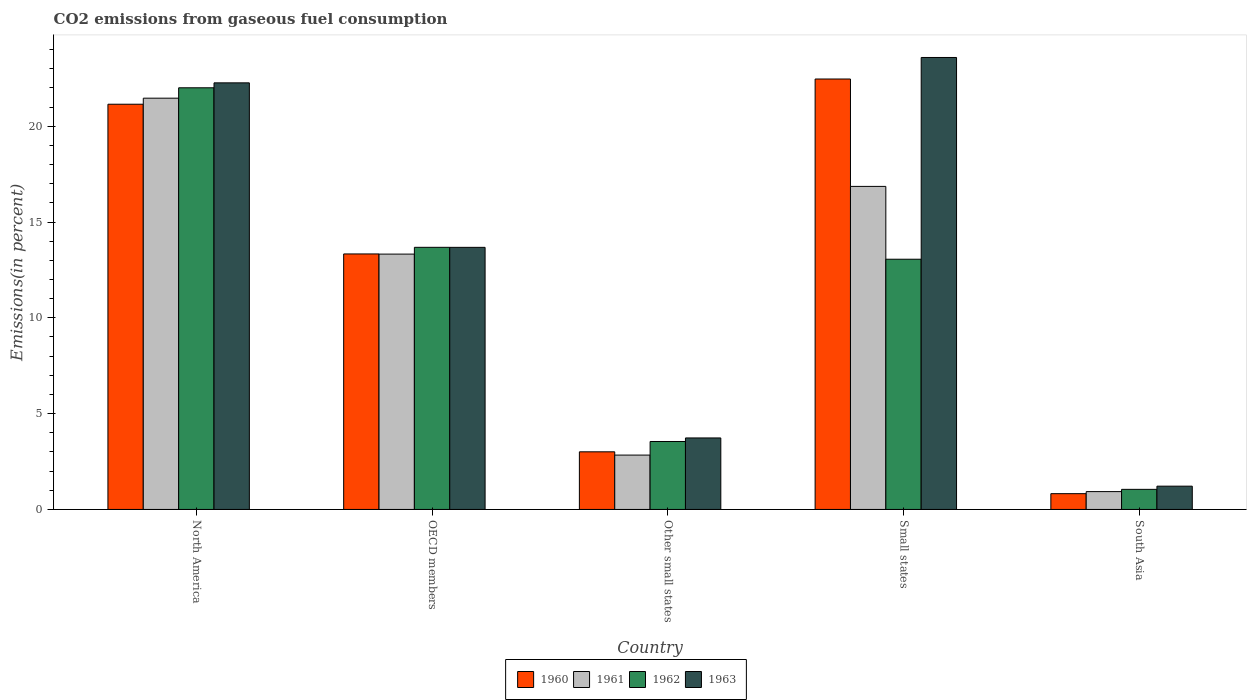How many groups of bars are there?
Make the answer very short. 5. Are the number of bars per tick equal to the number of legend labels?
Your response must be concise. Yes. How many bars are there on the 2nd tick from the right?
Provide a short and direct response. 4. In how many cases, is the number of bars for a given country not equal to the number of legend labels?
Your answer should be compact. 0. What is the total CO2 emitted in 1962 in OECD members?
Provide a short and direct response. 13.68. Across all countries, what is the maximum total CO2 emitted in 1960?
Make the answer very short. 22.46. Across all countries, what is the minimum total CO2 emitted in 1963?
Keep it short and to the point. 1.22. In which country was the total CO2 emitted in 1962 minimum?
Ensure brevity in your answer.  South Asia. What is the total total CO2 emitted in 1961 in the graph?
Offer a very short reply. 55.41. What is the difference between the total CO2 emitted in 1963 in OECD members and that in Other small states?
Your answer should be very brief. 9.95. What is the difference between the total CO2 emitted in 1962 in South Asia and the total CO2 emitted in 1961 in Other small states?
Provide a short and direct response. -1.79. What is the average total CO2 emitted in 1960 per country?
Offer a very short reply. 12.15. What is the difference between the total CO2 emitted of/in 1963 and total CO2 emitted of/in 1961 in Other small states?
Ensure brevity in your answer.  0.89. In how many countries, is the total CO2 emitted in 1963 greater than 13 %?
Your answer should be compact. 3. What is the ratio of the total CO2 emitted in 1963 in North America to that in Small states?
Offer a very short reply. 0.94. What is the difference between the highest and the second highest total CO2 emitted in 1962?
Your answer should be compact. -0.62. What is the difference between the highest and the lowest total CO2 emitted in 1963?
Provide a succinct answer. 22.37. What does the 3rd bar from the right in Other small states represents?
Keep it short and to the point. 1961. How many bars are there?
Your answer should be very brief. 20. Are all the bars in the graph horizontal?
Offer a terse response. No. How many countries are there in the graph?
Provide a short and direct response. 5. What is the difference between two consecutive major ticks on the Y-axis?
Your answer should be very brief. 5. Does the graph contain any zero values?
Your answer should be compact. No. Where does the legend appear in the graph?
Provide a succinct answer. Bottom center. What is the title of the graph?
Provide a short and direct response. CO2 emissions from gaseous fuel consumption. What is the label or title of the X-axis?
Ensure brevity in your answer.  Country. What is the label or title of the Y-axis?
Provide a succinct answer. Emissions(in percent). What is the Emissions(in percent) of 1960 in North America?
Offer a very short reply. 21.15. What is the Emissions(in percent) of 1961 in North America?
Your answer should be very brief. 21.46. What is the Emissions(in percent) in 1962 in North America?
Provide a succinct answer. 22. What is the Emissions(in percent) in 1963 in North America?
Provide a short and direct response. 22.26. What is the Emissions(in percent) of 1960 in OECD members?
Provide a short and direct response. 13.33. What is the Emissions(in percent) of 1961 in OECD members?
Offer a very short reply. 13.33. What is the Emissions(in percent) in 1962 in OECD members?
Provide a succinct answer. 13.68. What is the Emissions(in percent) in 1963 in OECD members?
Your answer should be very brief. 13.68. What is the Emissions(in percent) in 1960 in Other small states?
Give a very brief answer. 3.01. What is the Emissions(in percent) in 1961 in Other small states?
Keep it short and to the point. 2.84. What is the Emissions(in percent) in 1962 in Other small states?
Provide a short and direct response. 3.55. What is the Emissions(in percent) of 1963 in Other small states?
Offer a terse response. 3.73. What is the Emissions(in percent) in 1960 in Small states?
Provide a short and direct response. 22.46. What is the Emissions(in percent) in 1961 in Small states?
Your response must be concise. 16.86. What is the Emissions(in percent) of 1962 in Small states?
Offer a very short reply. 13.06. What is the Emissions(in percent) in 1963 in Small states?
Provide a short and direct response. 23.59. What is the Emissions(in percent) in 1960 in South Asia?
Offer a terse response. 0.82. What is the Emissions(in percent) of 1961 in South Asia?
Ensure brevity in your answer.  0.93. What is the Emissions(in percent) in 1962 in South Asia?
Keep it short and to the point. 1.05. What is the Emissions(in percent) in 1963 in South Asia?
Your answer should be compact. 1.22. Across all countries, what is the maximum Emissions(in percent) of 1960?
Provide a succinct answer. 22.46. Across all countries, what is the maximum Emissions(in percent) in 1961?
Offer a terse response. 21.46. Across all countries, what is the maximum Emissions(in percent) of 1962?
Your answer should be compact. 22. Across all countries, what is the maximum Emissions(in percent) in 1963?
Your answer should be compact. 23.59. Across all countries, what is the minimum Emissions(in percent) of 1960?
Offer a very short reply. 0.82. Across all countries, what is the minimum Emissions(in percent) of 1961?
Your answer should be very brief. 0.93. Across all countries, what is the minimum Emissions(in percent) of 1962?
Your answer should be compact. 1.05. Across all countries, what is the minimum Emissions(in percent) in 1963?
Your response must be concise. 1.22. What is the total Emissions(in percent) of 1960 in the graph?
Ensure brevity in your answer.  60.77. What is the total Emissions(in percent) in 1961 in the graph?
Your answer should be compact. 55.41. What is the total Emissions(in percent) of 1962 in the graph?
Your answer should be very brief. 53.34. What is the total Emissions(in percent) of 1963 in the graph?
Give a very brief answer. 64.47. What is the difference between the Emissions(in percent) in 1960 in North America and that in OECD members?
Provide a succinct answer. 7.81. What is the difference between the Emissions(in percent) in 1961 in North America and that in OECD members?
Give a very brief answer. 8.14. What is the difference between the Emissions(in percent) of 1962 in North America and that in OECD members?
Make the answer very short. 8.32. What is the difference between the Emissions(in percent) of 1963 in North America and that in OECD members?
Offer a very short reply. 8.58. What is the difference between the Emissions(in percent) in 1960 in North America and that in Other small states?
Make the answer very short. 18.14. What is the difference between the Emissions(in percent) in 1961 in North America and that in Other small states?
Give a very brief answer. 18.62. What is the difference between the Emissions(in percent) of 1962 in North America and that in Other small states?
Provide a succinct answer. 18.46. What is the difference between the Emissions(in percent) of 1963 in North America and that in Other small states?
Your answer should be compact. 18.53. What is the difference between the Emissions(in percent) of 1960 in North America and that in Small states?
Provide a succinct answer. -1.32. What is the difference between the Emissions(in percent) of 1961 in North America and that in Small states?
Your response must be concise. 4.6. What is the difference between the Emissions(in percent) in 1962 in North America and that in Small states?
Provide a succinct answer. 8.95. What is the difference between the Emissions(in percent) of 1963 in North America and that in Small states?
Your answer should be compact. -1.32. What is the difference between the Emissions(in percent) of 1960 in North America and that in South Asia?
Your answer should be very brief. 20.32. What is the difference between the Emissions(in percent) in 1961 in North America and that in South Asia?
Your response must be concise. 20.53. What is the difference between the Emissions(in percent) in 1962 in North America and that in South Asia?
Your answer should be very brief. 20.95. What is the difference between the Emissions(in percent) of 1963 in North America and that in South Asia?
Offer a very short reply. 21.05. What is the difference between the Emissions(in percent) in 1960 in OECD members and that in Other small states?
Your answer should be very brief. 10.33. What is the difference between the Emissions(in percent) in 1961 in OECD members and that in Other small states?
Ensure brevity in your answer.  10.49. What is the difference between the Emissions(in percent) in 1962 in OECD members and that in Other small states?
Give a very brief answer. 10.13. What is the difference between the Emissions(in percent) in 1963 in OECD members and that in Other small states?
Offer a terse response. 9.95. What is the difference between the Emissions(in percent) of 1960 in OECD members and that in Small states?
Your answer should be compact. -9.13. What is the difference between the Emissions(in percent) of 1961 in OECD members and that in Small states?
Keep it short and to the point. -3.53. What is the difference between the Emissions(in percent) in 1962 in OECD members and that in Small states?
Offer a terse response. 0.62. What is the difference between the Emissions(in percent) in 1963 in OECD members and that in Small states?
Offer a very short reply. -9.91. What is the difference between the Emissions(in percent) of 1960 in OECD members and that in South Asia?
Your response must be concise. 12.51. What is the difference between the Emissions(in percent) in 1961 in OECD members and that in South Asia?
Provide a short and direct response. 12.39. What is the difference between the Emissions(in percent) of 1962 in OECD members and that in South Asia?
Your answer should be compact. 12.63. What is the difference between the Emissions(in percent) in 1963 in OECD members and that in South Asia?
Make the answer very short. 12.46. What is the difference between the Emissions(in percent) in 1960 in Other small states and that in Small states?
Your answer should be very brief. -19.45. What is the difference between the Emissions(in percent) in 1961 in Other small states and that in Small states?
Keep it short and to the point. -14.02. What is the difference between the Emissions(in percent) in 1962 in Other small states and that in Small states?
Your answer should be compact. -9.51. What is the difference between the Emissions(in percent) of 1963 in Other small states and that in Small states?
Ensure brevity in your answer.  -19.85. What is the difference between the Emissions(in percent) of 1960 in Other small states and that in South Asia?
Your answer should be very brief. 2.18. What is the difference between the Emissions(in percent) in 1961 in Other small states and that in South Asia?
Offer a terse response. 1.91. What is the difference between the Emissions(in percent) of 1962 in Other small states and that in South Asia?
Offer a terse response. 2.5. What is the difference between the Emissions(in percent) of 1963 in Other small states and that in South Asia?
Your answer should be compact. 2.52. What is the difference between the Emissions(in percent) of 1960 in Small states and that in South Asia?
Make the answer very short. 21.64. What is the difference between the Emissions(in percent) in 1961 in Small states and that in South Asia?
Ensure brevity in your answer.  15.93. What is the difference between the Emissions(in percent) in 1962 in Small states and that in South Asia?
Give a very brief answer. 12.01. What is the difference between the Emissions(in percent) in 1963 in Small states and that in South Asia?
Offer a terse response. 22.37. What is the difference between the Emissions(in percent) in 1960 in North America and the Emissions(in percent) in 1961 in OECD members?
Give a very brief answer. 7.82. What is the difference between the Emissions(in percent) in 1960 in North America and the Emissions(in percent) in 1962 in OECD members?
Give a very brief answer. 7.47. What is the difference between the Emissions(in percent) in 1960 in North America and the Emissions(in percent) in 1963 in OECD members?
Offer a terse response. 7.47. What is the difference between the Emissions(in percent) in 1961 in North America and the Emissions(in percent) in 1962 in OECD members?
Your response must be concise. 7.78. What is the difference between the Emissions(in percent) in 1961 in North America and the Emissions(in percent) in 1963 in OECD members?
Ensure brevity in your answer.  7.78. What is the difference between the Emissions(in percent) in 1962 in North America and the Emissions(in percent) in 1963 in OECD members?
Offer a very short reply. 8.33. What is the difference between the Emissions(in percent) of 1960 in North America and the Emissions(in percent) of 1961 in Other small states?
Your answer should be compact. 18.31. What is the difference between the Emissions(in percent) of 1960 in North America and the Emissions(in percent) of 1962 in Other small states?
Make the answer very short. 17.6. What is the difference between the Emissions(in percent) of 1960 in North America and the Emissions(in percent) of 1963 in Other small states?
Offer a terse response. 17.41. What is the difference between the Emissions(in percent) of 1961 in North America and the Emissions(in percent) of 1962 in Other small states?
Offer a terse response. 17.92. What is the difference between the Emissions(in percent) in 1961 in North America and the Emissions(in percent) in 1963 in Other small states?
Keep it short and to the point. 17.73. What is the difference between the Emissions(in percent) of 1962 in North America and the Emissions(in percent) of 1963 in Other small states?
Provide a short and direct response. 18.27. What is the difference between the Emissions(in percent) in 1960 in North America and the Emissions(in percent) in 1961 in Small states?
Your answer should be very brief. 4.29. What is the difference between the Emissions(in percent) of 1960 in North America and the Emissions(in percent) of 1962 in Small states?
Offer a very short reply. 8.09. What is the difference between the Emissions(in percent) of 1960 in North America and the Emissions(in percent) of 1963 in Small states?
Offer a very short reply. -2.44. What is the difference between the Emissions(in percent) of 1961 in North America and the Emissions(in percent) of 1962 in Small states?
Provide a succinct answer. 8.4. What is the difference between the Emissions(in percent) of 1961 in North America and the Emissions(in percent) of 1963 in Small states?
Your answer should be very brief. -2.12. What is the difference between the Emissions(in percent) in 1962 in North America and the Emissions(in percent) in 1963 in Small states?
Your response must be concise. -1.58. What is the difference between the Emissions(in percent) of 1960 in North America and the Emissions(in percent) of 1961 in South Asia?
Give a very brief answer. 20.21. What is the difference between the Emissions(in percent) in 1960 in North America and the Emissions(in percent) in 1962 in South Asia?
Make the answer very short. 20.1. What is the difference between the Emissions(in percent) of 1960 in North America and the Emissions(in percent) of 1963 in South Asia?
Provide a short and direct response. 19.93. What is the difference between the Emissions(in percent) in 1961 in North America and the Emissions(in percent) in 1962 in South Asia?
Make the answer very short. 20.41. What is the difference between the Emissions(in percent) of 1961 in North America and the Emissions(in percent) of 1963 in South Asia?
Your response must be concise. 20.25. What is the difference between the Emissions(in percent) in 1962 in North America and the Emissions(in percent) in 1963 in South Asia?
Your answer should be very brief. 20.79. What is the difference between the Emissions(in percent) of 1960 in OECD members and the Emissions(in percent) of 1961 in Other small states?
Your answer should be compact. 10.5. What is the difference between the Emissions(in percent) of 1960 in OECD members and the Emissions(in percent) of 1962 in Other small states?
Offer a terse response. 9.79. What is the difference between the Emissions(in percent) of 1960 in OECD members and the Emissions(in percent) of 1963 in Other small states?
Provide a short and direct response. 9.6. What is the difference between the Emissions(in percent) of 1961 in OECD members and the Emissions(in percent) of 1962 in Other small states?
Provide a short and direct response. 9.78. What is the difference between the Emissions(in percent) of 1961 in OECD members and the Emissions(in percent) of 1963 in Other small states?
Provide a short and direct response. 9.59. What is the difference between the Emissions(in percent) in 1962 in OECD members and the Emissions(in percent) in 1963 in Other small states?
Offer a terse response. 9.95. What is the difference between the Emissions(in percent) of 1960 in OECD members and the Emissions(in percent) of 1961 in Small states?
Provide a short and direct response. -3.52. What is the difference between the Emissions(in percent) in 1960 in OECD members and the Emissions(in percent) in 1962 in Small states?
Provide a succinct answer. 0.28. What is the difference between the Emissions(in percent) of 1960 in OECD members and the Emissions(in percent) of 1963 in Small states?
Your answer should be compact. -10.25. What is the difference between the Emissions(in percent) in 1961 in OECD members and the Emissions(in percent) in 1962 in Small states?
Your answer should be compact. 0.27. What is the difference between the Emissions(in percent) in 1961 in OECD members and the Emissions(in percent) in 1963 in Small states?
Make the answer very short. -10.26. What is the difference between the Emissions(in percent) in 1962 in OECD members and the Emissions(in percent) in 1963 in Small states?
Offer a very short reply. -9.91. What is the difference between the Emissions(in percent) of 1960 in OECD members and the Emissions(in percent) of 1961 in South Asia?
Provide a succinct answer. 12.4. What is the difference between the Emissions(in percent) in 1960 in OECD members and the Emissions(in percent) in 1962 in South Asia?
Provide a succinct answer. 12.28. What is the difference between the Emissions(in percent) in 1960 in OECD members and the Emissions(in percent) in 1963 in South Asia?
Give a very brief answer. 12.12. What is the difference between the Emissions(in percent) in 1961 in OECD members and the Emissions(in percent) in 1962 in South Asia?
Your response must be concise. 12.28. What is the difference between the Emissions(in percent) in 1961 in OECD members and the Emissions(in percent) in 1963 in South Asia?
Keep it short and to the point. 12.11. What is the difference between the Emissions(in percent) in 1962 in OECD members and the Emissions(in percent) in 1963 in South Asia?
Your response must be concise. 12.46. What is the difference between the Emissions(in percent) of 1960 in Other small states and the Emissions(in percent) of 1961 in Small states?
Your answer should be compact. -13.85. What is the difference between the Emissions(in percent) of 1960 in Other small states and the Emissions(in percent) of 1962 in Small states?
Give a very brief answer. -10.05. What is the difference between the Emissions(in percent) of 1960 in Other small states and the Emissions(in percent) of 1963 in Small states?
Ensure brevity in your answer.  -20.58. What is the difference between the Emissions(in percent) in 1961 in Other small states and the Emissions(in percent) in 1962 in Small states?
Keep it short and to the point. -10.22. What is the difference between the Emissions(in percent) of 1961 in Other small states and the Emissions(in percent) of 1963 in Small states?
Provide a succinct answer. -20.75. What is the difference between the Emissions(in percent) of 1962 in Other small states and the Emissions(in percent) of 1963 in Small states?
Provide a succinct answer. -20.04. What is the difference between the Emissions(in percent) of 1960 in Other small states and the Emissions(in percent) of 1961 in South Asia?
Ensure brevity in your answer.  2.08. What is the difference between the Emissions(in percent) in 1960 in Other small states and the Emissions(in percent) in 1962 in South Asia?
Offer a very short reply. 1.96. What is the difference between the Emissions(in percent) in 1960 in Other small states and the Emissions(in percent) in 1963 in South Asia?
Provide a succinct answer. 1.79. What is the difference between the Emissions(in percent) of 1961 in Other small states and the Emissions(in percent) of 1962 in South Asia?
Provide a short and direct response. 1.79. What is the difference between the Emissions(in percent) in 1961 in Other small states and the Emissions(in percent) in 1963 in South Asia?
Offer a terse response. 1.62. What is the difference between the Emissions(in percent) of 1962 in Other small states and the Emissions(in percent) of 1963 in South Asia?
Your answer should be very brief. 2.33. What is the difference between the Emissions(in percent) of 1960 in Small states and the Emissions(in percent) of 1961 in South Asia?
Provide a short and direct response. 21.53. What is the difference between the Emissions(in percent) in 1960 in Small states and the Emissions(in percent) in 1962 in South Asia?
Offer a terse response. 21.41. What is the difference between the Emissions(in percent) in 1960 in Small states and the Emissions(in percent) in 1963 in South Asia?
Your answer should be very brief. 21.25. What is the difference between the Emissions(in percent) in 1961 in Small states and the Emissions(in percent) in 1962 in South Asia?
Keep it short and to the point. 15.81. What is the difference between the Emissions(in percent) in 1961 in Small states and the Emissions(in percent) in 1963 in South Asia?
Offer a very short reply. 15.64. What is the difference between the Emissions(in percent) in 1962 in Small states and the Emissions(in percent) in 1963 in South Asia?
Your answer should be compact. 11.84. What is the average Emissions(in percent) of 1960 per country?
Give a very brief answer. 12.15. What is the average Emissions(in percent) of 1961 per country?
Offer a very short reply. 11.08. What is the average Emissions(in percent) in 1962 per country?
Your response must be concise. 10.67. What is the average Emissions(in percent) in 1963 per country?
Give a very brief answer. 12.89. What is the difference between the Emissions(in percent) in 1960 and Emissions(in percent) in 1961 in North America?
Give a very brief answer. -0.32. What is the difference between the Emissions(in percent) of 1960 and Emissions(in percent) of 1962 in North America?
Your answer should be very brief. -0.86. What is the difference between the Emissions(in percent) of 1960 and Emissions(in percent) of 1963 in North America?
Keep it short and to the point. -1.12. What is the difference between the Emissions(in percent) of 1961 and Emissions(in percent) of 1962 in North America?
Keep it short and to the point. -0.54. What is the difference between the Emissions(in percent) in 1962 and Emissions(in percent) in 1963 in North America?
Ensure brevity in your answer.  -0.26. What is the difference between the Emissions(in percent) of 1960 and Emissions(in percent) of 1961 in OECD members?
Provide a succinct answer. 0.01. What is the difference between the Emissions(in percent) of 1960 and Emissions(in percent) of 1962 in OECD members?
Provide a succinct answer. -0.35. What is the difference between the Emissions(in percent) of 1960 and Emissions(in percent) of 1963 in OECD members?
Your answer should be very brief. -0.34. What is the difference between the Emissions(in percent) of 1961 and Emissions(in percent) of 1962 in OECD members?
Offer a very short reply. -0.35. What is the difference between the Emissions(in percent) in 1961 and Emissions(in percent) in 1963 in OECD members?
Provide a short and direct response. -0.35. What is the difference between the Emissions(in percent) of 1962 and Emissions(in percent) of 1963 in OECD members?
Your answer should be compact. 0. What is the difference between the Emissions(in percent) of 1960 and Emissions(in percent) of 1961 in Other small states?
Provide a short and direct response. 0.17. What is the difference between the Emissions(in percent) in 1960 and Emissions(in percent) in 1962 in Other small states?
Make the answer very short. -0.54. What is the difference between the Emissions(in percent) of 1960 and Emissions(in percent) of 1963 in Other small states?
Your answer should be very brief. -0.72. What is the difference between the Emissions(in percent) in 1961 and Emissions(in percent) in 1962 in Other small states?
Provide a short and direct response. -0.71. What is the difference between the Emissions(in percent) of 1961 and Emissions(in percent) of 1963 in Other small states?
Your answer should be compact. -0.89. What is the difference between the Emissions(in percent) of 1962 and Emissions(in percent) of 1963 in Other small states?
Your answer should be compact. -0.19. What is the difference between the Emissions(in percent) in 1960 and Emissions(in percent) in 1961 in Small states?
Your answer should be compact. 5.6. What is the difference between the Emissions(in percent) in 1960 and Emissions(in percent) in 1962 in Small states?
Make the answer very short. 9.41. What is the difference between the Emissions(in percent) of 1960 and Emissions(in percent) of 1963 in Small states?
Offer a very short reply. -1.12. What is the difference between the Emissions(in percent) of 1961 and Emissions(in percent) of 1962 in Small states?
Make the answer very short. 3.8. What is the difference between the Emissions(in percent) of 1961 and Emissions(in percent) of 1963 in Small states?
Give a very brief answer. -6.73. What is the difference between the Emissions(in percent) of 1962 and Emissions(in percent) of 1963 in Small states?
Give a very brief answer. -10.53. What is the difference between the Emissions(in percent) in 1960 and Emissions(in percent) in 1961 in South Asia?
Your answer should be very brief. -0.11. What is the difference between the Emissions(in percent) of 1960 and Emissions(in percent) of 1962 in South Asia?
Keep it short and to the point. -0.22. What is the difference between the Emissions(in percent) in 1960 and Emissions(in percent) in 1963 in South Asia?
Your response must be concise. -0.39. What is the difference between the Emissions(in percent) of 1961 and Emissions(in percent) of 1962 in South Asia?
Keep it short and to the point. -0.12. What is the difference between the Emissions(in percent) of 1961 and Emissions(in percent) of 1963 in South Asia?
Keep it short and to the point. -0.28. What is the difference between the Emissions(in percent) of 1962 and Emissions(in percent) of 1963 in South Asia?
Give a very brief answer. -0.17. What is the ratio of the Emissions(in percent) of 1960 in North America to that in OECD members?
Your response must be concise. 1.59. What is the ratio of the Emissions(in percent) of 1961 in North America to that in OECD members?
Keep it short and to the point. 1.61. What is the ratio of the Emissions(in percent) in 1962 in North America to that in OECD members?
Offer a terse response. 1.61. What is the ratio of the Emissions(in percent) in 1963 in North America to that in OECD members?
Your answer should be compact. 1.63. What is the ratio of the Emissions(in percent) of 1960 in North America to that in Other small states?
Provide a succinct answer. 7.03. What is the ratio of the Emissions(in percent) in 1961 in North America to that in Other small states?
Make the answer very short. 7.57. What is the ratio of the Emissions(in percent) of 1962 in North America to that in Other small states?
Keep it short and to the point. 6.21. What is the ratio of the Emissions(in percent) of 1963 in North America to that in Other small states?
Make the answer very short. 5.97. What is the ratio of the Emissions(in percent) of 1960 in North America to that in Small states?
Your answer should be very brief. 0.94. What is the ratio of the Emissions(in percent) of 1961 in North America to that in Small states?
Your response must be concise. 1.27. What is the ratio of the Emissions(in percent) in 1962 in North America to that in Small states?
Your answer should be compact. 1.69. What is the ratio of the Emissions(in percent) in 1963 in North America to that in Small states?
Provide a short and direct response. 0.94. What is the ratio of the Emissions(in percent) in 1960 in North America to that in South Asia?
Your answer should be very brief. 25.66. What is the ratio of the Emissions(in percent) in 1961 in North America to that in South Asia?
Provide a short and direct response. 23.03. What is the ratio of the Emissions(in percent) in 1962 in North America to that in South Asia?
Your answer should be very brief. 20.98. What is the ratio of the Emissions(in percent) in 1963 in North America to that in South Asia?
Your answer should be very brief. 18.32. What is the ratio of the Emissions(in percent) in 1960 in OECD members to that in Other small states?
Offer a terse response. 4.43. What is the ratio of the Emissions(in percent) of 1961 in OECD members to that in Other small states?
Provide a short and direct response. 4.7. What is the ratio of the Emissions(in percent) in 1962 in OECD members to that in Other small states?
Your answer should be compact. 3.86. What is the ratio of the Emissions(in percent) of 1963 in OECD members to that in Other small states?
Make the answer very short. 3.67. What is the ratio of the Emissions(in percent) in 1960 in OECD members to that in Small states?
Ensure brevity in your answer.  0.59. What is the ratio of the Emissions(in percent) in 1961 in OECD members to that in Small states?
Your response must be concise. 0.79. What is the ratio of the Emissions(in percent) in 1962 in OECD members to that in Small states?
Keep it short and to the point. 1.05. What is the ratio of the Emissions(in percent) of 1963 in OECD members to that in Small states?
Provide a succinct answer. 0.58. What is the ratio of the Emissions(in percent) in 1960 in OECD members to that in South Asia?
Provide a short and direct response. 16.18. What is the ratio of the Emissions(in percent) of 1961 in OECD members to that in South Asia?
Your answer should be very brief. 14.3. What is the ratio of the Emissions(in percent) of 1962 in OECD members to that in South Asia?
Offer a very short reply. 13.04. What is the ratio of the Emissions(in percent) of 1963 in OECD members to that in South Asia?
Offer a terse response. 11.26. What is the ratio of the Emissions(in percent) in 1960 in Other small states to that in Small states?
Provide a succinct answer. 0.13. What is the ratio of the Emissions(in percent) in 1961 in Other small states to that in Small states?
Offer a very short reply. 0.17. What is the ratio of the Emissions(in percent) of 1962 in Other small states to that in Small states?
Your answer should be very brief. 0.27. What is the ratio of the Emissions(in percent) in 1963 in Other small states to that in Small states?
Give a very brief answer. 0.16. What is the ratio of the Emissions(in percent) in 1960 in Other small states to that in South Asia?
Provide a succinct answer. 3.65. What is the ratio of the Emissions(in percent) in 1961 in Other small states to that in South Asia?
Your answer should be very brief. 3.04. What is the ratio of the Emissions(in percent) in 1962 in Other small states to that in South Asia?
Provide a short and direct response. 3.38. What is the ratio of the Emissions(in percent) in 1963 in Other small states to that in South Asia?
Provide a succinct answer. 3.07. What is the ratio of the Emissions(in percent) of 1960 in Small states to that in South Asia?
Offer a terse response. 27.26. What is the ratio of the Emissions(in percent) in 1961 in Small states to that in South Asia?
Ensure brevity in your answer.  18.09. What is the ratio of the Emissions(in percent) in 1962 in Small states to that in South Asia?
Make the answer very short. 12.45. What is the ratio of the Emissions(in percent) in 1963 in Small states to that in South Asia?
Give a very brief answer. 19.41. What is the difference between the highest and the second highest Emissions(in percent) in 1960?
Keep it short and to the point. 1.32. What is the difference between the highest and the second highest Emissions(in percent) in 1961?
Keep it short and to the point. 4.6. What is the difference between the highest and the second highest Emissions(in percent) in 1962?
Offer a very short reply. 8.32. What is the difference between the highest and the second highest Emissions(in percent) in 1963?
Make the answer very short. 1.32. What is the difference between the highest and the lowest Emissions(in percent) of 1960?
Your answer should be compact. 21.64. What is the difference between the highest and the lowest Emissions(in percent) in 1961?
Your response must be concise. 20.53. What is the difference between the highest and the lowest Emissions(in percent) in 1962?
Ensure brevity in your answer.  20.95. What is the difference between the highest and the lowest Emissions(in percent) of 1963?
Your answer should be compact. 22.37. 